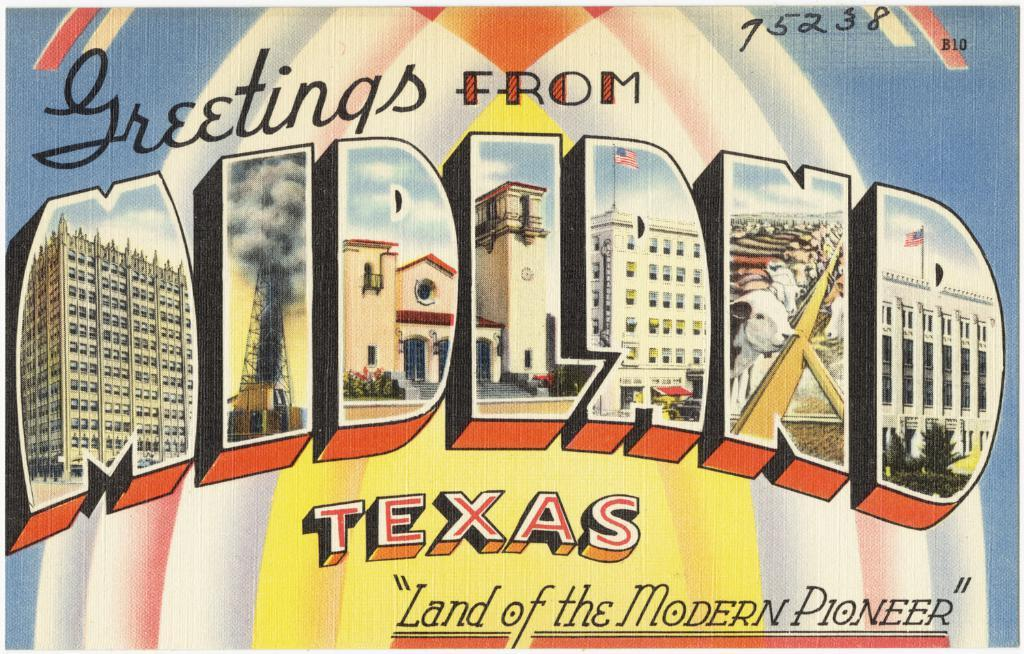<image>
Relay a brief, clear account of the picture shown. A postcard that says greetings from Midland Texas, land of the modern pioneer, with pictures of tourist sites. 